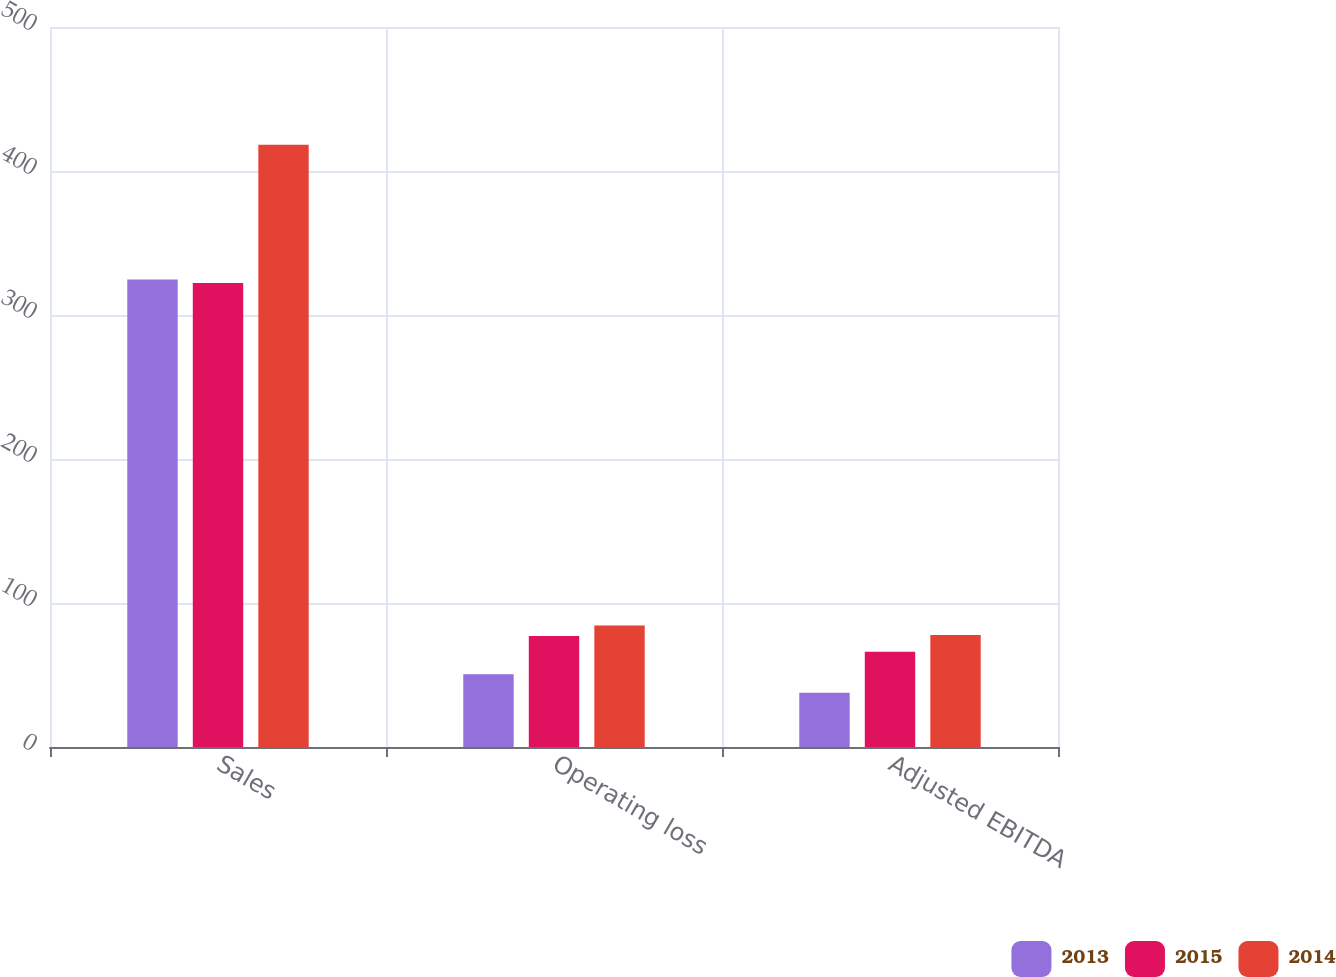<chart> <loc_0><loc_0><loc_500><loc_500><stacked_bar_chart><ecel><fcel>Sales<fcel>Operating loss<fcel>Adjusted EBITDA<nl><fcel>2013<fcel>324.7<fcel>50.6<fcel>37.6<nl><fcel>2015<fcel>322.2<fcel>77<fcel>66.2<nl><fcel>2014<fcel>418.3<fcel>84.3<fcel>77.8<nl></chart> 